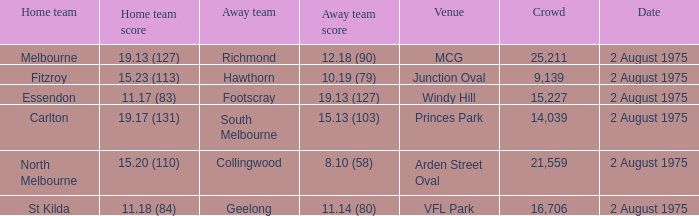Write the full table. {'header': ['Home team', 'Home team score', 'Away team', 'Away team score', 'Venue', 'Crowd', 'Date'], 'rows': [['Melbourne', '19.13 (127)', 'Richmond', '12.18 (90)', 'MCG', '25,211', '2 August 1975'], ['Fitzroy', '15.23 (113)', 'Hawthorn', '10.19 (79)', 'Junction Oval', '9,139', '2 August 1975'], ['Essendon', '11.17 (83)', 'Footscray', '19.13 (127)', 'Windy Hill', '15,227', '2 August 1975'], ['Carlton', '19.17 (131)', 'South Melbourne', '15.13 (103)', 'Princes Park', '14,039', '2 August 1975'], ['North Melbourne', '15.20 (110)', 'Collingwood', '8.10 (58)', 'Arden Street Oval', '21,559', '2 August 1975'], ['St Kilda', '11.18 (84)', 'Geelong', '11.14 (80)', 'VFL Park', '16,706', '2 August 1975']]} 18 (84)? VFL Park. 